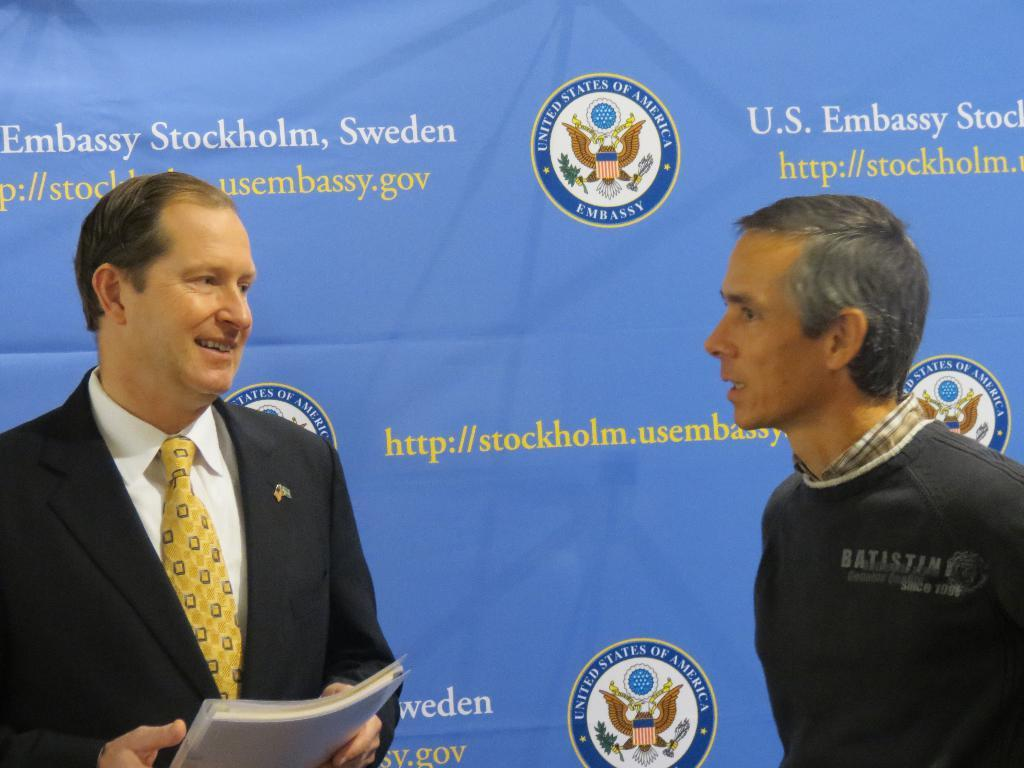How many people are in the foreground of the image? There are two men in the foreground of the image. What is one of the men holding? One of the men is holding a book. What can be seen in the background of the image? There is a banner in the background of the image. What type of stone is the book made of in the image? The book is not made of stone; it is a typical book made of paper and cardboard. What theory is being discussed by the men in the image? There is no indication in the image of a specific theory being discussed by the men. 